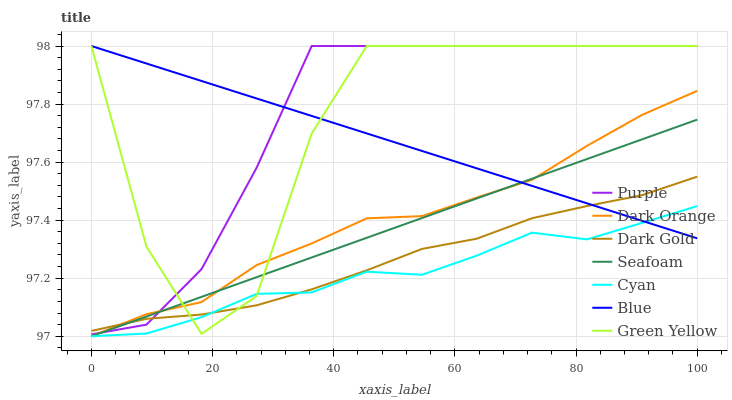Does Cyan have the minimum area under the curve?
Answer yes or no. Yes. Does Purple have the maximum area under the curve?
Answer yes or no. Yes. Does Dark Orange have the minimum area under the curve?
Answer yes or no. No. Does Dark Orange have the maximum area under the curve?
Answer yes or no. No. Is Blue the smoothest?
Answer yes or no. Yes. Is Green Yellow the roughest?
Answer yes or no. Yes. Is Dark Orange the smoothest?
Answer yes or no. No. Is Dark Orange the roughest?
Answer yes or no. No. Does Dark Orange have the lowest value?
Answer yes or no. Yes. Does Dark Gold have the lowest value?
Answer yes or no. No. Does Green Yellow have the highest value?
Answer yes or no. Yes. Does Dark Orange have the highest value?
Answer yes or no. No. Is Cyan less than Purple?
Answer yes or no. Yes. Is Purple greater than Cyan?
Answer yes or no. Yes. Does Seafoam intersect Green Yellow?
Answer yes or no. Yes. Is Seafoam less than Green Yellow?
Answer yes or no. No. Is Seafoam greater than Green Yellow?
Answer yes or no. No. Does Cyan intersect Purple?
Answer yes or no. No. 